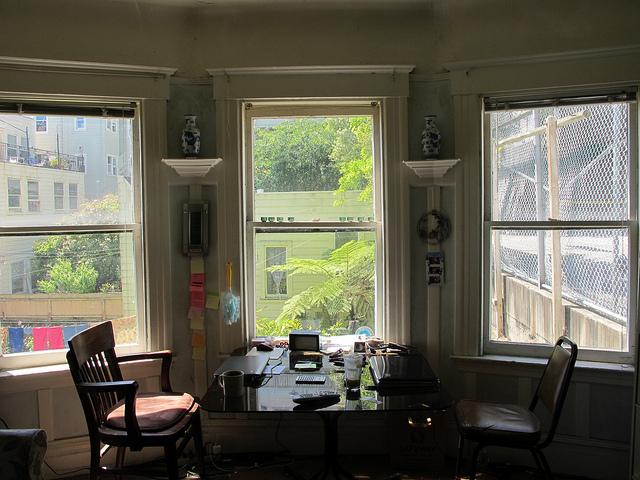How many chairs are around the table?
Keep it brief. 2. How many windows are on the building?
Be succinct. 3. Is anybody sitting in these chairs?
Short answer required. No. What time of day is it?
Concise answer only. Afternoon. What room of the house is this?
Concise answer only. Dining room. 